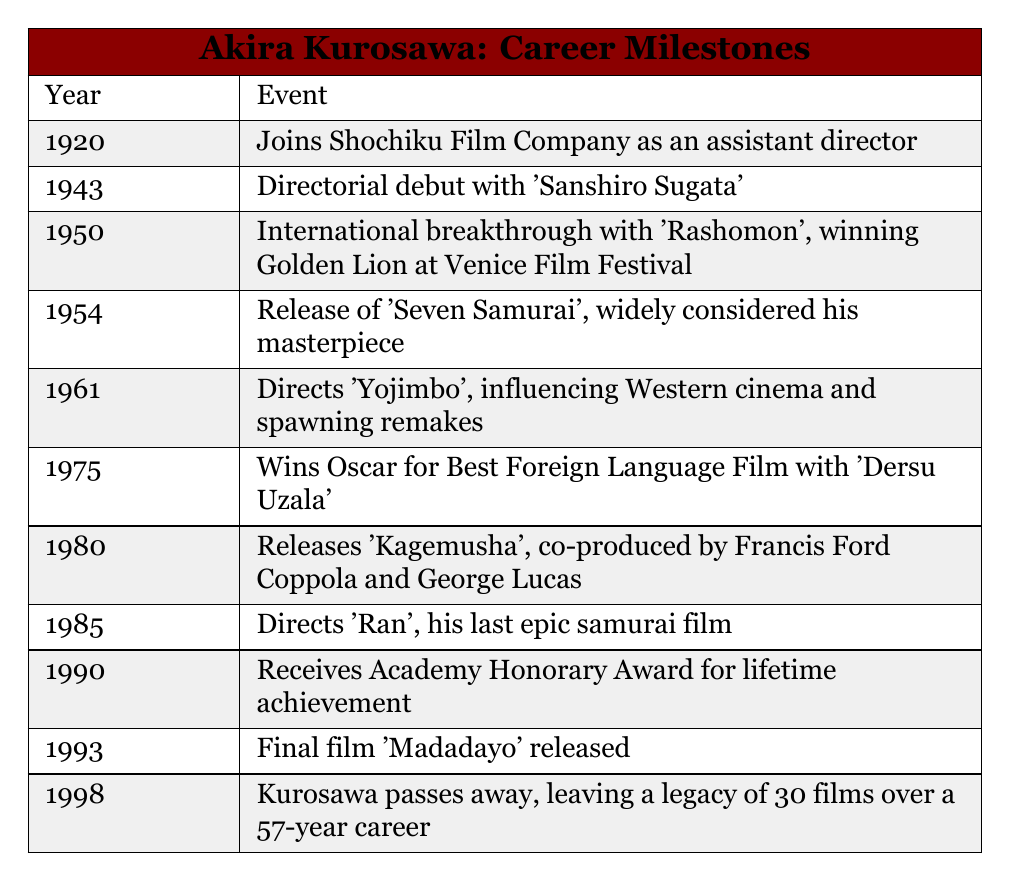What year did Akira Kurosawa direct his first film? According to the table, Kurosawa's directorial debut was with "Sanshiro Sugata," which occurred in the year 1943.
Answer: 1943 In which year was "Seven Samurai" released? The table explicitly states that "Seven Samurai" was released in 1954.
Answer: 1954 Did Kurosawa win an Oscar for his film "Dersu Uzala"? The table indicates that he won the Oscar for Best Foreign Language Film with "Dersu Uzala" in 1975, confirming that the statement is true.
Answer: Yes How many years apart were the releases of "Ran" and his final film "Madadayo"? "Ran" was released in 1985 and "Madadayo" was released in 1993. The difference in years is 1993 - 1985 = 8 years.
Answer: 8 years What is the total number of films Akira Kurosawa directed over his career? The table states that he left a legacy of 30 films, which directly answers the question about the total number.
Answer: 30 In what year did Kurosawa join Shochiku Film Company? Referring to the table, Kurosawa joined Shochiku Film Company in 1920.
Answer: 1920 Which film marked Kurosawa's international breakthrough? The table notes that "Rashomon," released in 1950, was his international breakthrough and won the Golden Lion at the Venice Film Festival.
Answer: Rashomon For how many years did Kurosawa actively direct films from his debut to his final film? Kurosawa debuted in 1943 and his final film was released in 1993. The duration is 1993 - 1943 = 50 years of active directing.
Answer: 50 years Did Akira Kurosawa's career span more than 50 years? The table reveals that he had a career lasting 57 years, thus confirming that the statement is true.
Answer: Yes 